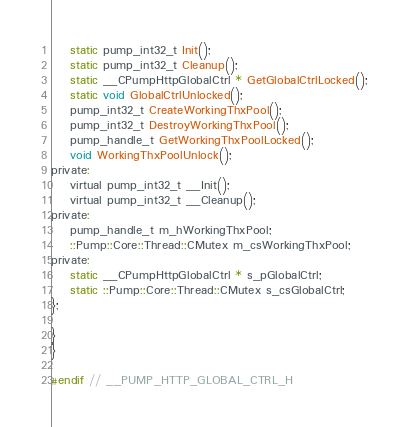<code> <loc_0><loc_0><loc_500><loc_500><_C_>    static pump_int32_t Init();
    static pump_int32_t Cleanup();
    static __CPumpHttpGlobalCtrl * GetGlobalCtrlLocked();
    static void GlobalCtrlUnlocked();
    pump_int32_t CreateWorkingThxPool();
    pump_int32_t DestroyWorkingThxPool();
    pump_handle_t GetWorkingThxPoolLocked();
    void WorkingThxPoolUnlock();
private:
    virtual pump_int32_t __Init();
    virtual pump_int32_t __Cleanup();
private:
    pump_handle_t m_hWorkingThxPool;
    ::Pump::Core::Thread::CMutex m_csWorkingThxPool;
private:
    static __CPumpHttpGlobalCtrl * s_pGlobalCtrl;
    static ::Pump::Core::Thread::CMutex s_csGlobalCtrl;
};

}
}

#endif // __PUMP_HTTP_GLOBAL_CTRL_H</code> 